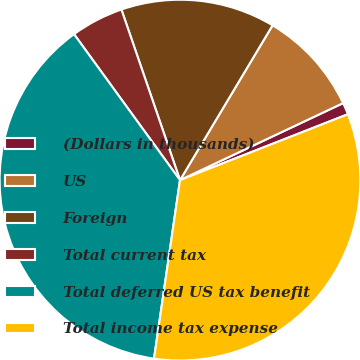Convert chart to OTSL. <chart><loc_0><loc_0><loc_500><loc_500><pie_chart><fcel>(Dollars in thousands)<fcel>US<fcel>Foreign<fcel>Total current tax<fcel>Total deferred US tax benefit<fcel>Total income tax expense<nl><fcel>1.07%<fcel>9.4%<fcel>13.84%<fcel>4.73%<fcel>37.7%<fcel>33.25%<nl></chart> 